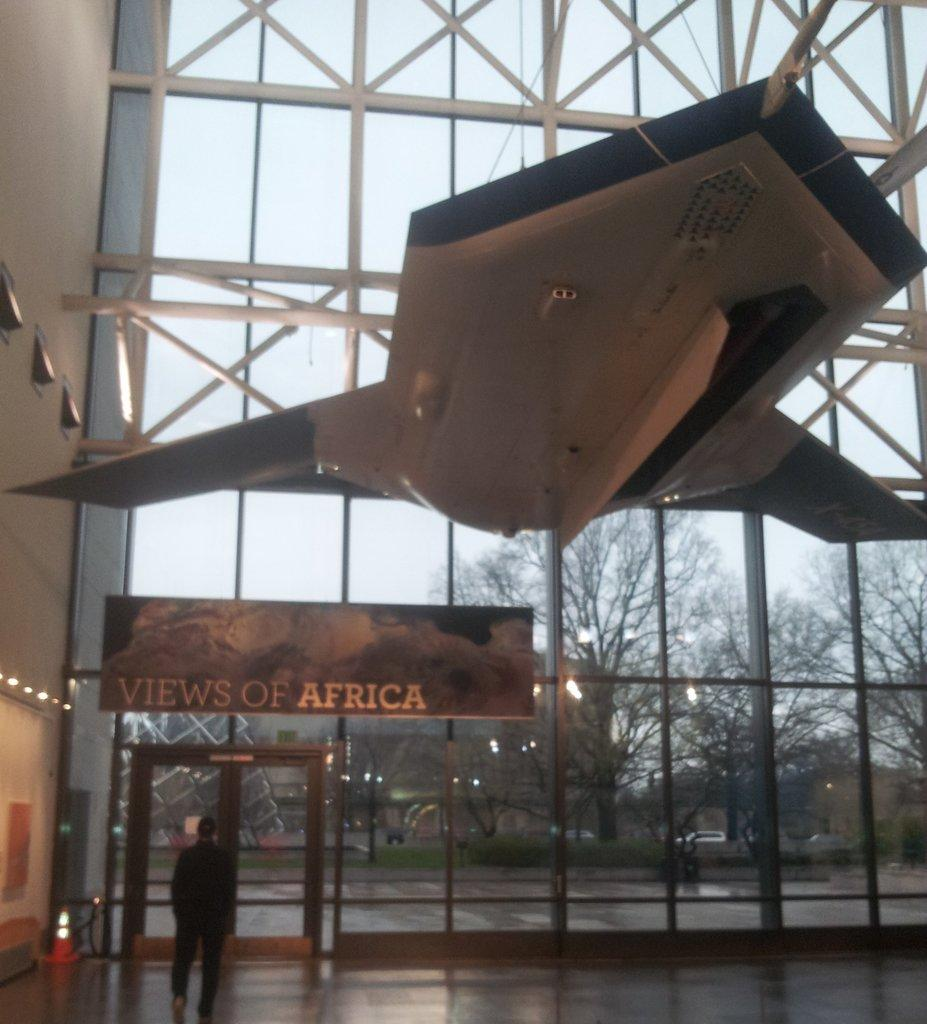Provide a one-sentence caption for the provided image. A big glass wall with a banner of views to Africa on it. 